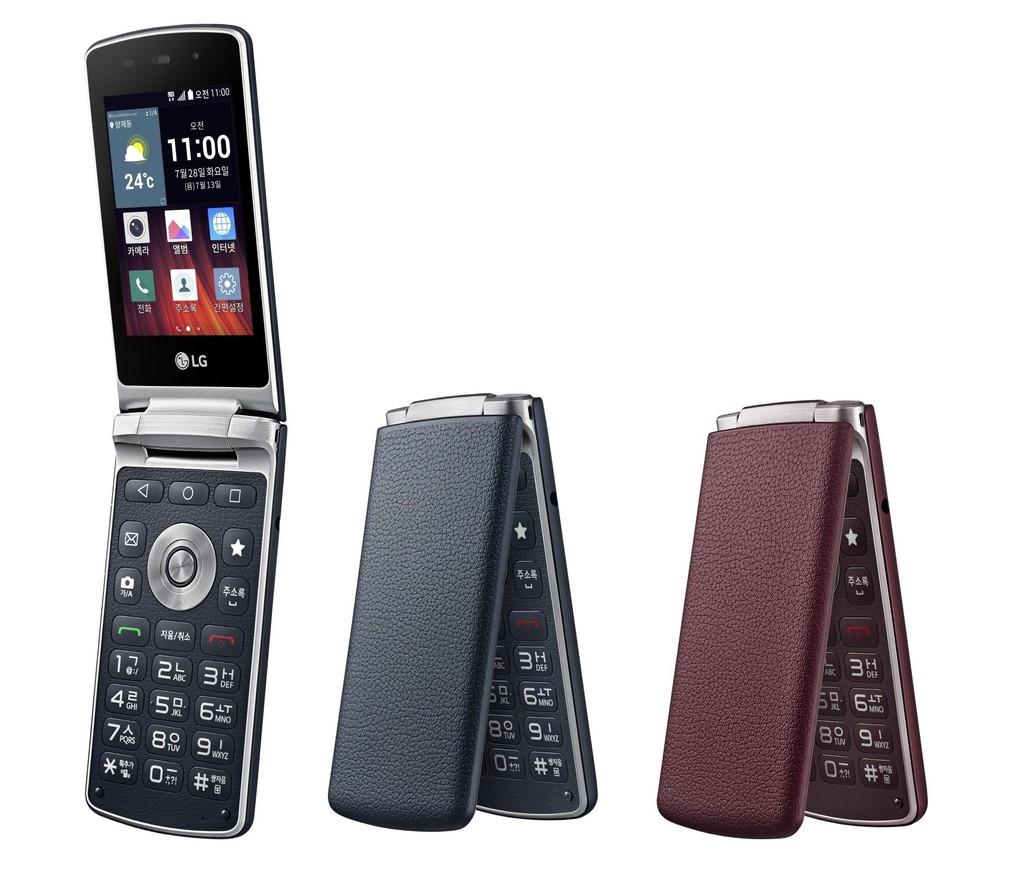What brand is the phone?
Make the answer very short. Lg. What time is shown on open phone?
Provide a short and direct response. 11:00. 